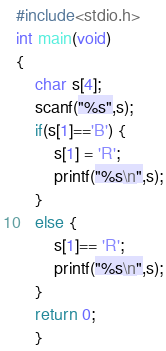Convert code to text. <code><loc_0><loc_0><loc_500><loc_500><_C++_>#include<stdio.h>
int main(void)
{
    char s[4];
	scanf("%s",s);
	if(s[1]=='B') {
		s[1] = 'R';
		printf("%s\n",s);
	}
	else {
		s[1]== 'R';
		printf("%s\n",s);
	}
	return 0;
	}</code> 